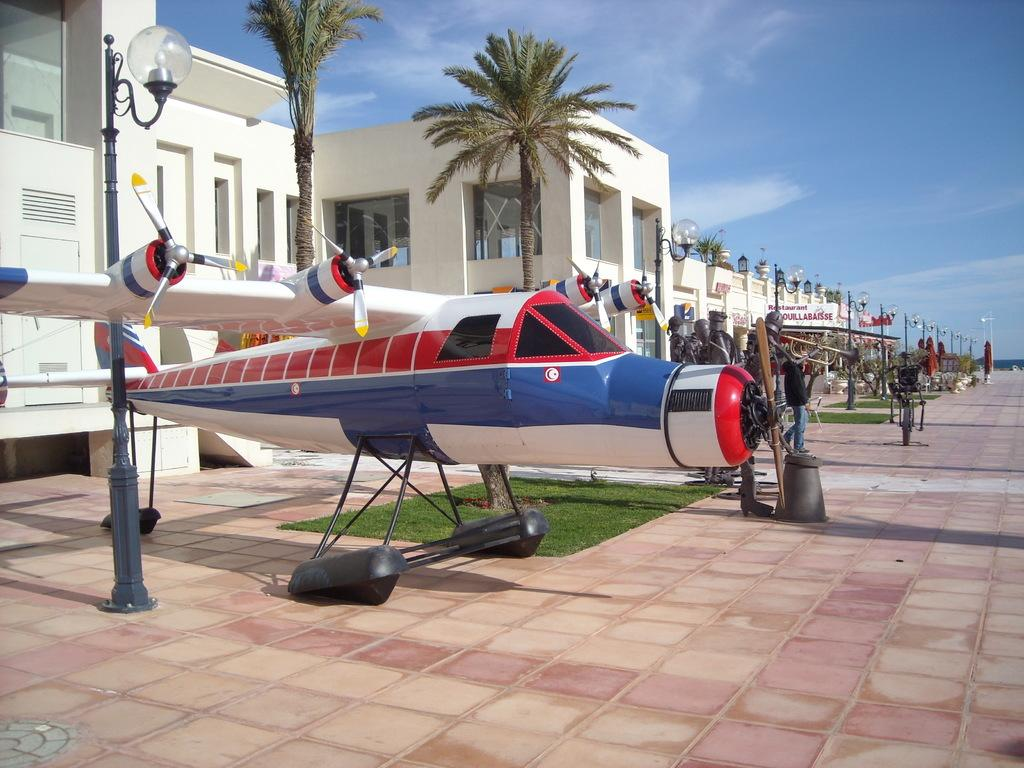What is the main subject of the image? The main subject of the image is an aircraft. What type of natural environment can be seen in the image? There are trees and grass in the image, indicating a natural environment. What type of structures are present in the image? There are buildings and light poles in the image. What is visible in the sky in the image? The sky is visible in the image. Are there any people present in the image? Yes, there are people in the image. What else can be seen in the image besides the main subject and the people? There are objects in the image. What is the price of the peace symbol in the image? There is no peace symbol present in the image, and therefore no price can be determined. What type of stem is growing from the aircraft in the image? There is no stem growing from the aircraft in the image. 